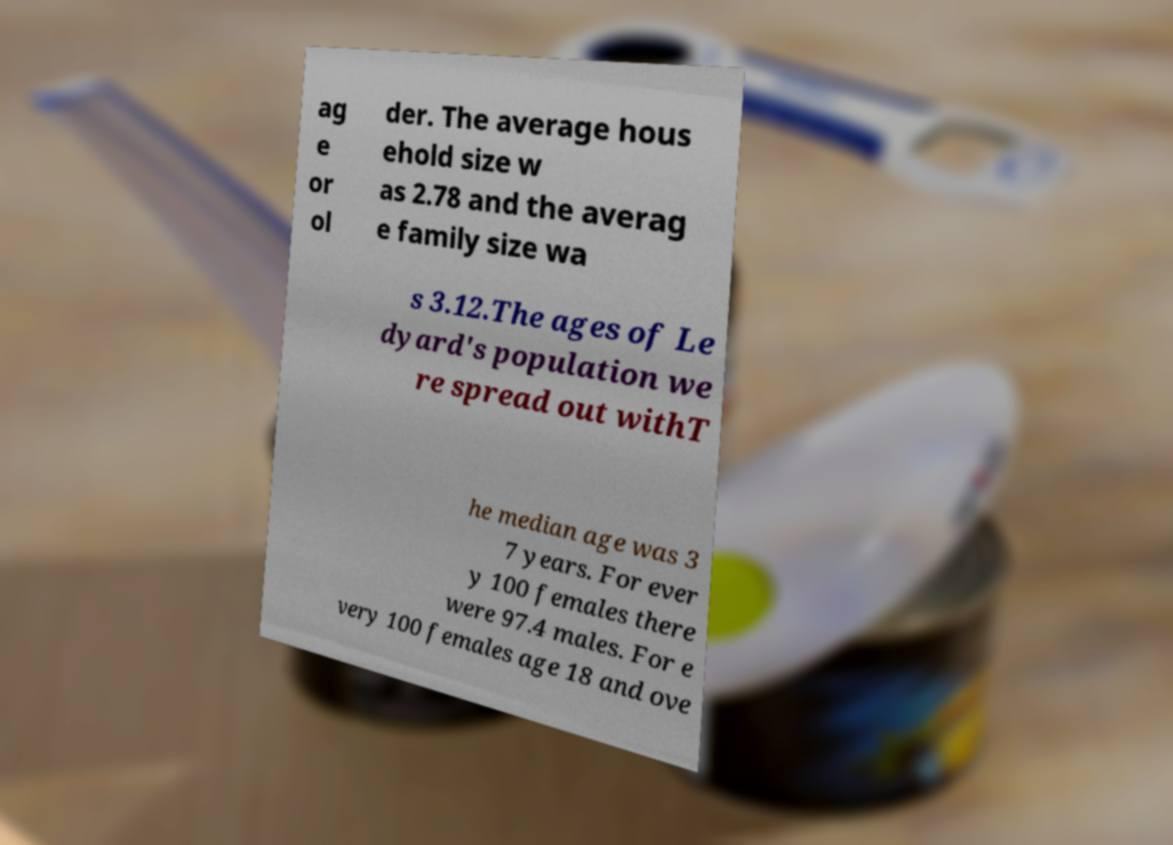Please identify and transcribe the text found in this image. ag e or ol der. The average hous ehold size w as 2.78 and the averag e family size wa s 3.12.The ages of Le dyard's population we re spread out withT he median age was 3 7 years. For ever y 100 females there were 97.4 males. For e very 100 females age 18 and ove 